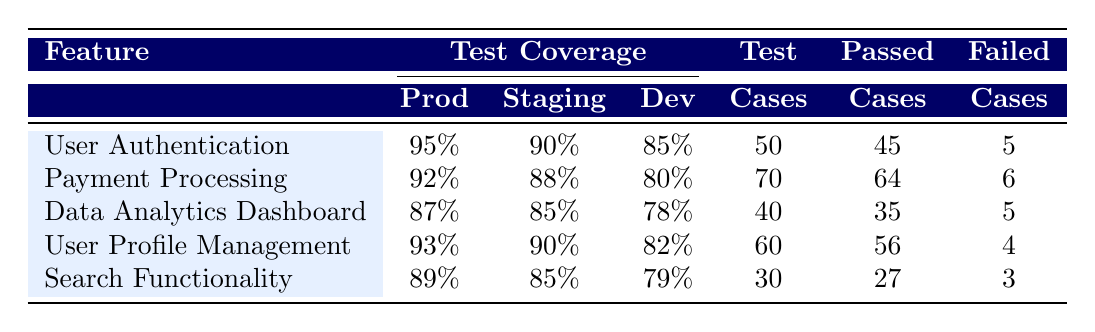What is the test coverage for User Authentication in the production environment? The table lists the test coverage for each feature under different environments. For User Authentication, the production coverage is marked as 95%.
Answer: 95% What is the lowest test coverage among all features in the development environment? To find the lowest coverage in development, we can compare the values: 85% (User Authentication), 80% (Payment Processing), 78% (Data Analytics Dashboard), 82% (User Profile Management), and 79% (Search Functionality). The lowest is 78% for Data Analytics Dashboard.
Answer: 78% Did the Search Functionality pass more test cases than it failed? For Search Functionality, there are 30 test cases with 27 passed and 3 failed. Since 27 is greater than 3, it indicates that more cases passed.
Answer: Yes Which feature has the highest number of test cases, and what is its production coverage? By reviewing the table, Payment Processing has the highest number of test cases at 70. Its production coverage is 92%.
Answer: Payment Processing, 92% What is the average passed test cases across all features? To calculate the average, we sum the passed cases (45 + 64 + 35 + 56 + 27 = 227) and divide by the number of features (5). Thus, the average passed cases are 227/5 = 45.4, which rounds to 45.
Answer: 45 Which feature in staging has lower coverage than in production? Comparing the staging coverage to production for each feature: User Authentication (90% < 95%), Payment Processing (88% < 92%), Data Analytics Dashboard (85% < 87%), User Profile Management (90% < 93%), and Search Functionality (85% < 89%). All features have lower staging coverage than production.
Answer: All features What is the difference in test coverage of User Profile Management between production and development? User Profile Management has production coverage of 93% and development coverage of 82%. To find the difference, we subtract 82 from 93, which results in 11%.
Answer: 11% In which environment did the Data Analytics Dashboard have the highest test coverage? The Data Analytics Dashboard has production coverage of 87%, staging coverage of 85%, and development coverage of 78%. Therefore, production has the highest coverage for this feature.
Answer: Production What percentage of failed test cases comes from the Payment Processing feature? For Payment Processing, there are 6 failed cases out of a total of 70 test cases. The percentage of failed cases is calculated as (6/70) * 100 = 8.57%.
Answer: 8.57% 